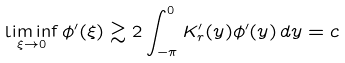<formula> <loc_0><loc_0><loc_500><loc_500>\liminf _ { \xi \to 0 } \phi ^ { \prime } ( \xi ) \gtrsim 2 \int _ { - \pi } ^ { 0 } K _ { r } ^ { \prime } ( y ) \phi ^ { \prime } ( y ) \, d y = c</formula> 